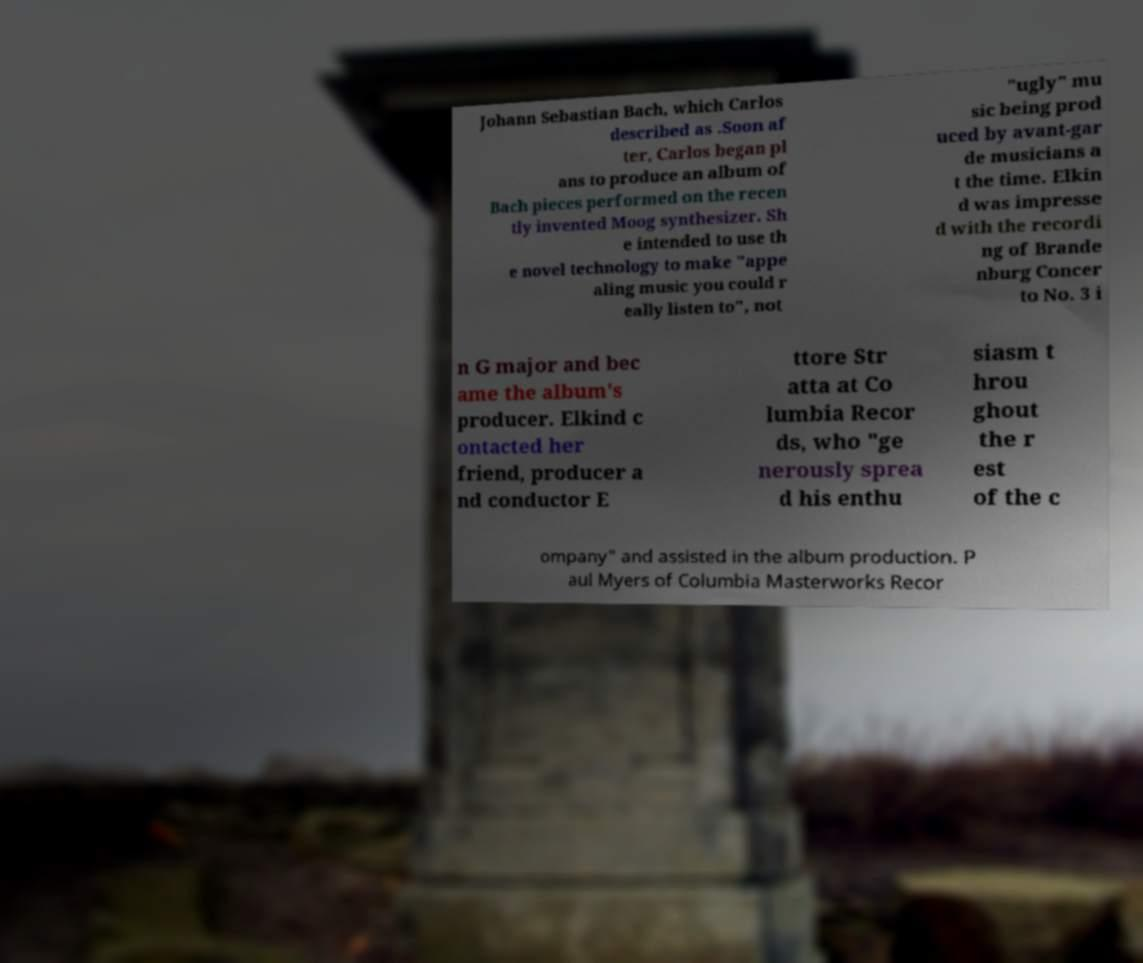Could you assist in decoding the text presented in this image and type it out clearly? Johann Sebastian Bach, which Carlos described as .Soon af ter, Carlos began pl ans to produce an album of Bach pieces performed on the recen tly invented Moog synthesizer. Sh e intended to use th e novel technology to make "appe aling music you could r eally listen to", not "ugly" mu sic being prod uced by avant-gar de musicians a t the time. Elkin d was impresse d with the recordi ng of Brande nburg Concer to No. 3 i n G major and bec ame the album's producer. Elkind c ontacted her friend, producer a nd conductor E ttore Str atta at Co lumbia Recor ds, who "ge nerously sprea d his enthu siasm t hrou ghout the r est of the c ompany" and assisted in the album production. P aul Myers of Columbia Masterworks Recor 